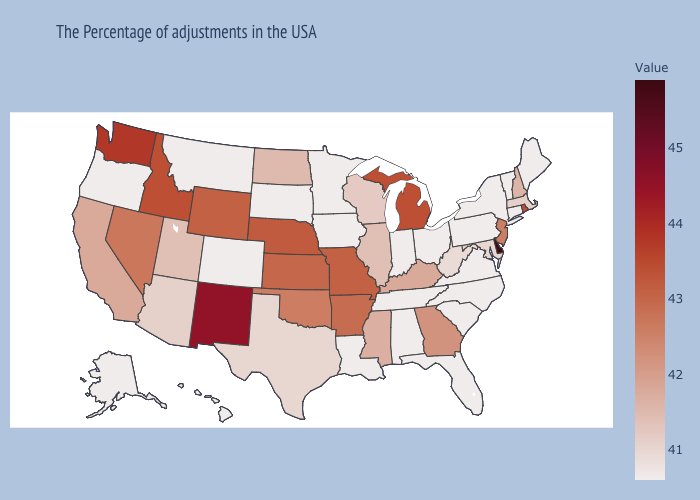Does Colorado have a lower value than Delaware?
Write a very short answer. Yes. Among the states that border Colorado , does Arizona have the lowest value?
Keep it brief. Yes. Which states have the highest value in the USA?
Be succinct. Delaware. Among the states that border Texas , which have the lowest value?
Give a very brief answer. Louisiana. Among the states that border Illinois , does Iowa have the lowest value?
Keep it brief. Yes. Among the states that border Delaware , which have the highest value?
Be succinct. New Jersey. Does North Dakota have the highest value in the MidWest?
Short answer required. No. 